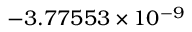<formula> <loc_0><loc_0><loc_500><loc_500>- 3 . 7 7 5 5 3 \times 1 0 ^ { - 9 }</formula> 